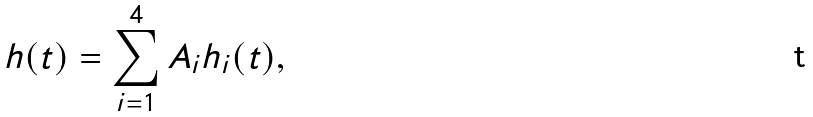Convert formula to latex. <formula><loc_0><loc_0><loc_500><loc_500>h ( t ) = \sum _ { i = 1 } ^ { 4 } A _ { i } h _ { i } ( t ) ,</formula> 